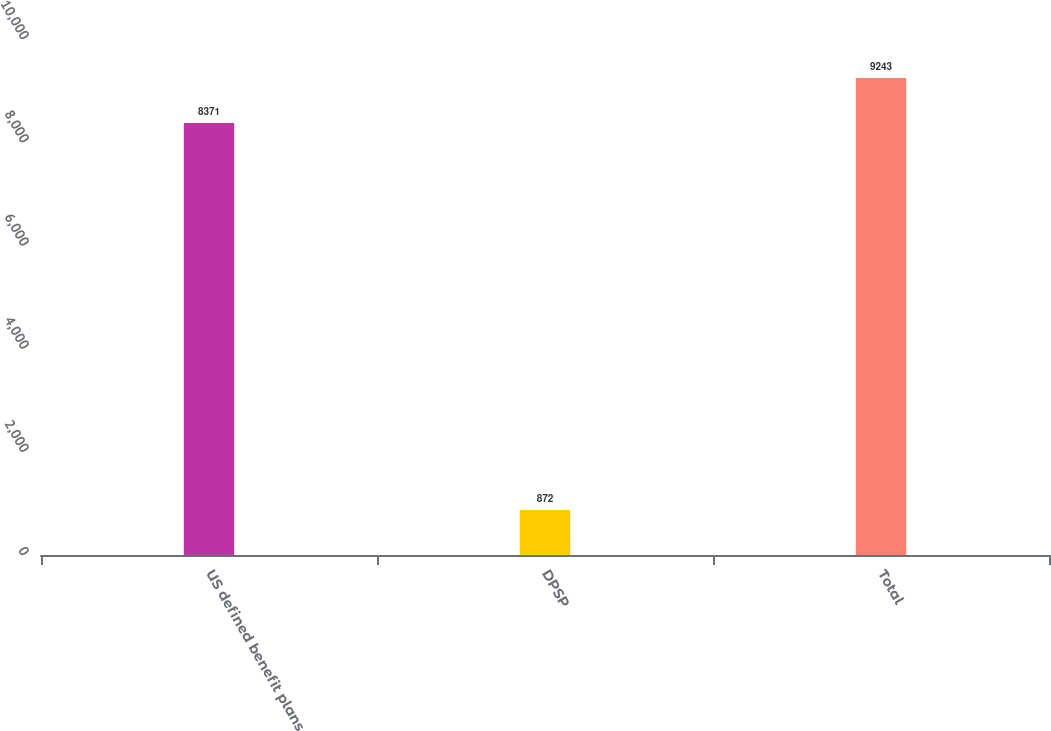<chart> <loc_0><loc_0><loc_500><loc_500><bar_chart><fcel>US defined benefit plans<fcel>DPSP<fcel>Total<nl><fcel>8371<fcel>872<fcel>9243<nl></chart> 